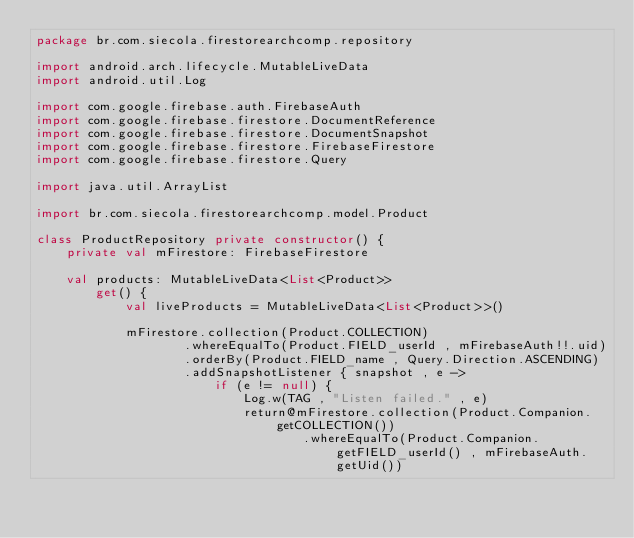Convert code to text. <code><loc_0><loc_0><loc_500><loc_500><_Kotlin_>package br.com.siecola.firestorearchcomp.repository

import android.arch.lifecycle.MutableLiveData
import android.util.Log

import com.google.firebase.auth.FirebaseAuth
import com.google.firebase.firestore.DocumentReference
import com.google.firebase.firestore.DocumentSnapshot
import com.google.firebase.firestore.FirebaseFirestore
import com.google.firebase.firestore.Query

import java.util.ArrayList

import br.com.siecola.firestorearchcomp.model.Product

class ProductRepository private constructor() {
    private val mFirestore: FirebaseFirestore

    val products: MutableLiveData<List<Product>>
        get() {
            val liveProducts = MutableLiveData<List<Product>>()

            mFirestore.collection(Product.COLLECTION)
                    .whereEqualTo(Product.FIELD_userId , mFirebaseAuth!!.uid)
                    .orderBy(Product.FIELD_name , Query.Direction.ASCENDING)
                    .addSnapshotListener { snapshot , e ->
                        if (e != null) {
                            Log.w(TAG , "Listen failed." , e)
                            return@mFirestore.collection(Product.Companion.getCOLLECTION())
                                    .whereEqualTo(Product.Companion.getFIELD_userId() , mFirebaseAuth.getUid())</code> 